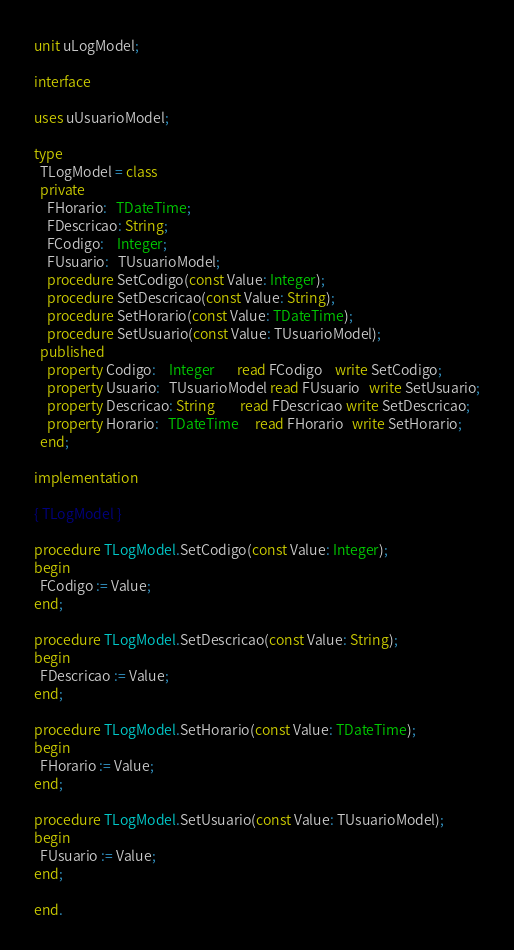Convert code to text. <code><loc_0><loc_0><loc_500><loc_500><_Pascal_>unit uLogModel;

interface

uses uUsuarioModel;

type
  TLogModel = class
  private
    FHorario:   TDateTime;
    FDescricao: String;
    FCodigo:    Integer;
    FUsuario:   TUsuarioModel;
    procedure SetCodigo(const Value: Integer);
    procedure SetDescricao(const Value: String);
    procedure SetHorario(const Value: TDateTime);
    procedure SetUsuario(const Value: TUsuarioModel);
  published
    property Codigo:    Integer       read FCodigo    write SetCodigo;
    property Usuario:   TUsuarioModel read FUsuario   write SetUsuario;
    property Descricao: String        read FDescricao write SetDescricao;
    property Horario:   TDateTime     read FHorario   write SetHorario;
  end;

implementation

{ TLogModel }

procedure TLogModel.SetCodigo(const Value: Integer);
begin
  FCodigo := Value;
end;

procedure TLogModel.SetDescricao(const Value: String);
begin
  FDescricao := Value;
end;

procedure TLogModel.SetHorario(const Value: TDateTime);
begin
  FHorario := Value;
end;

procedure TLogModel.SetUsuario(const Value: TUsuarioModel);
begin
  FUsuario := Value;
end;

end.
</code> 